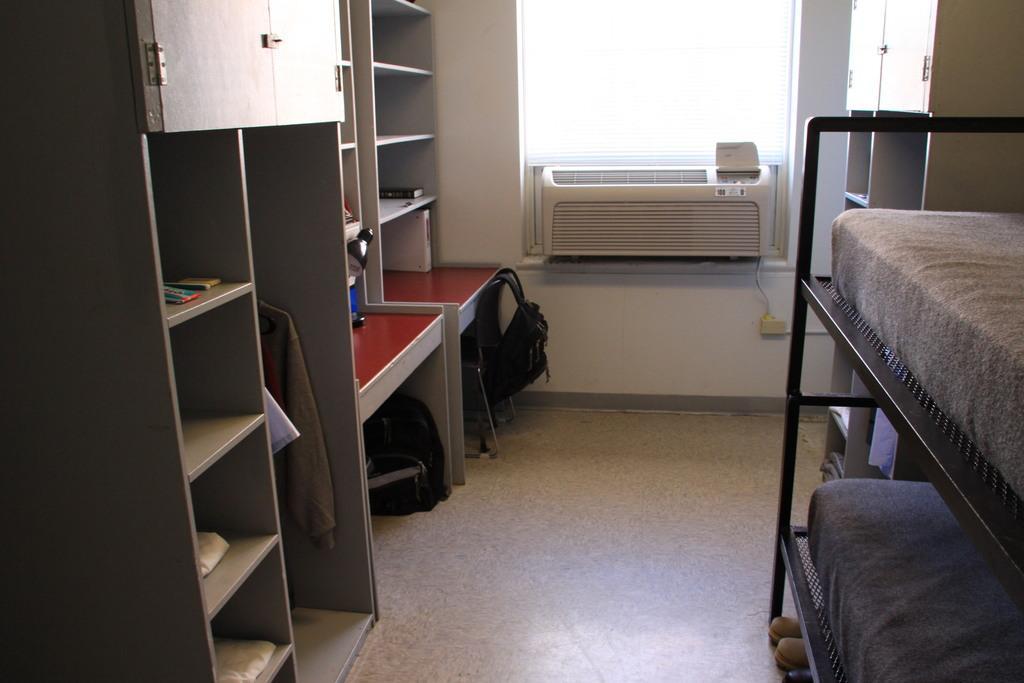Describe this image in one or two sentences. This is an inside view of a room. On the right side there are two bunk beds. On the left side there are few racks in which some objects are placed. Beside that there is table and also there are two bags. In the background there is an air conditioner which is placed near the window. Behind these bunk beds there is a cupboard. 